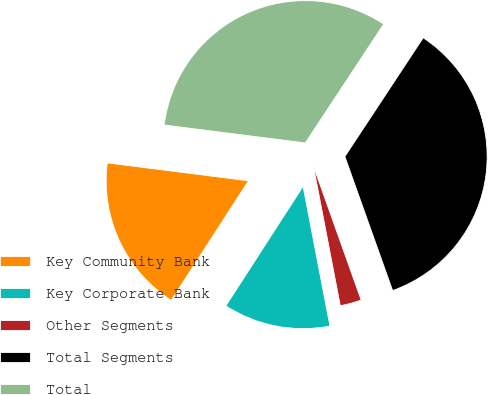Convert chart. <chart><loc_0><loc_0><loc_500><loc_500><pie_chart><fcel>Key Community Bank<fcel>Key Corporate Bank<fcel>Other Segments<fcel>Total Segments<fcel>Total<nl><fcel>17.88%<fcel>12.15%<fcel>2.42%<fcel>35.27%<fcel>32.27%<nl></chart> 